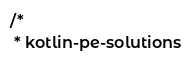<code> <loc_0><loc_0><loc_500><loc_500><_Kotlin_>/*
 * kotlin-pe-solutions</code> 